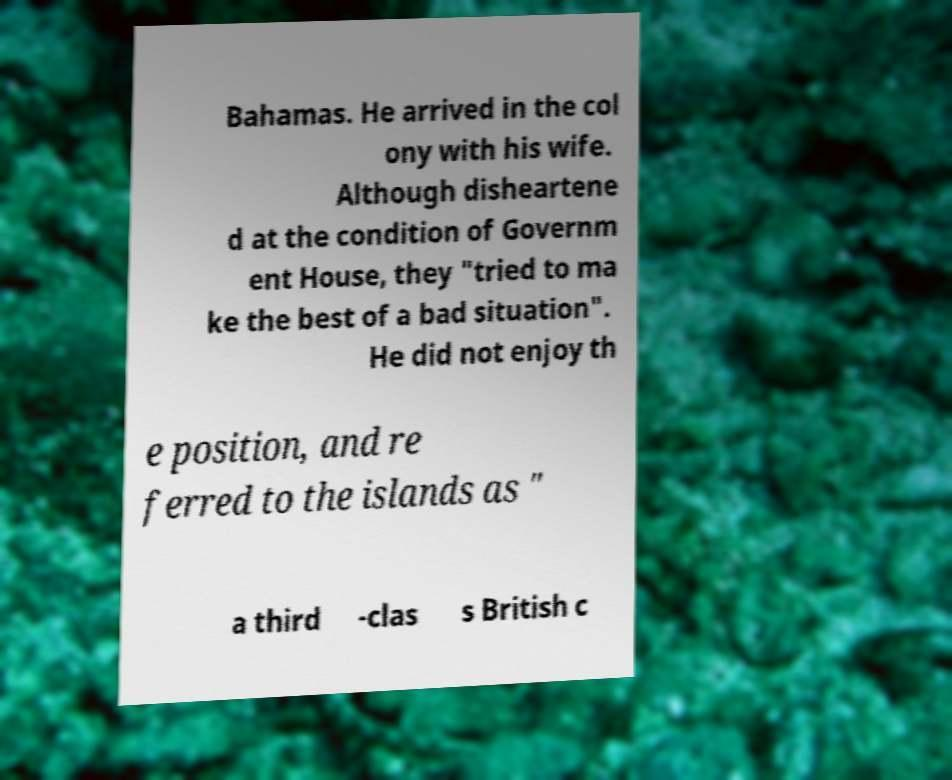Can you accurately transcribe the text from the provided image for me? Bahamas. He arrived in the col ony with his wife. Although disheartene d at the condition of Governm ent House, they "tried to ma ke the best of a bad situation". He did not enjoy th e position, and re ferred to the islands as " a third -clas s British c 